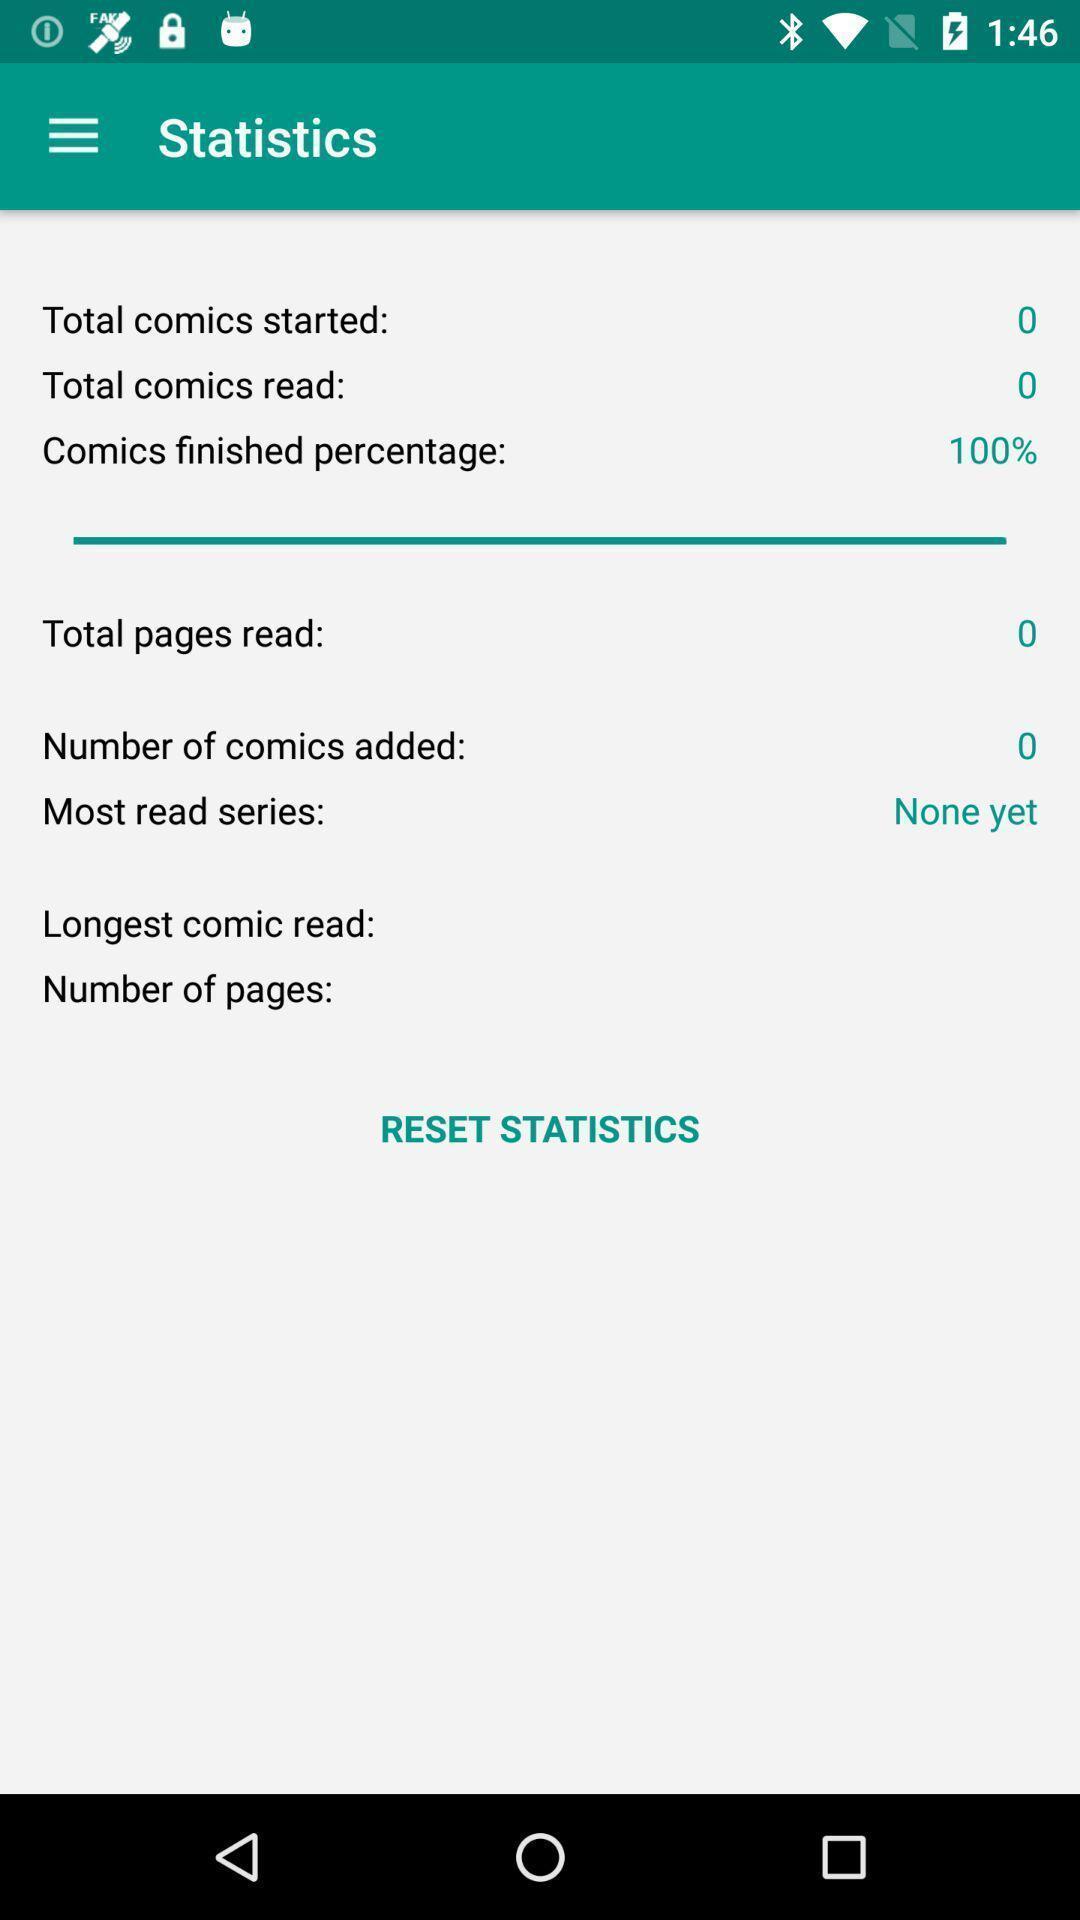Give me a narrative description of this picture. Statistics page displayed. 